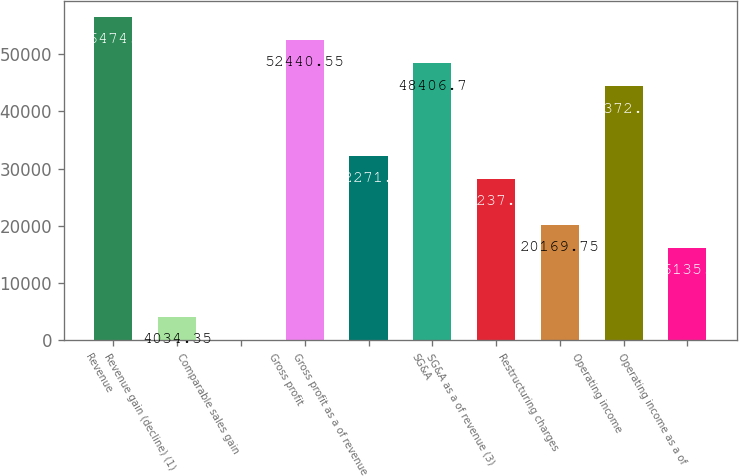Convert chart. <chart><loc_0><loc_0><loc_500><loc_500><bar_chart><fcel>Revenue<fcel>Revenue gain (decline) (1)<fcel>Comparable sales gain<fcel>Gross profit<fcel>Gross profit as a of revenue<fcel>SG&A<fcel>SG&A as a of revenue (3)<fcel>Restructuring charges<fcel>Operating income<fcel>Operating income as a of<nl><fcel>56474.4<fcel>4034.35<fcel>0.5<fcel>52440.6<fcel>32271.3<fcel>48406.7<fcel>28237.5<fcel>20169.8<fcel>44372.8<fcel>16135.9<nl></chart> 